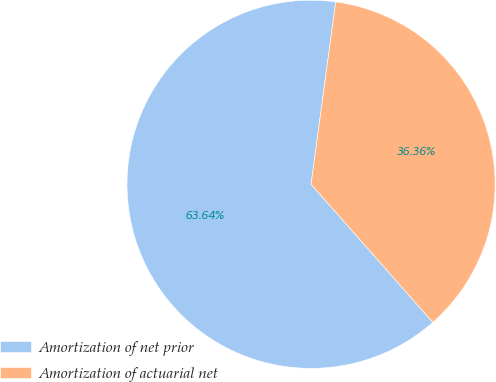<chart> <loc_0><loc_0><loc_500><loc_500><pie_chart><fcel>Amortization of net prior<fcel>Amortization of actuarial net<nl><fcel>63.64%<fcel>36.36%<nl></chart> 